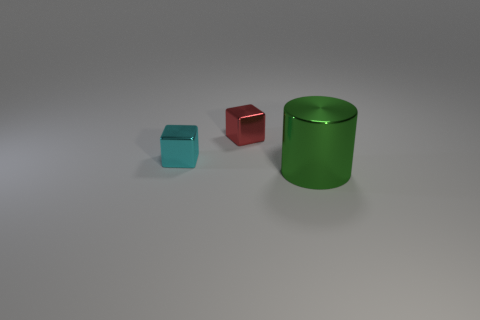What number of large green cylinders are there? 1 